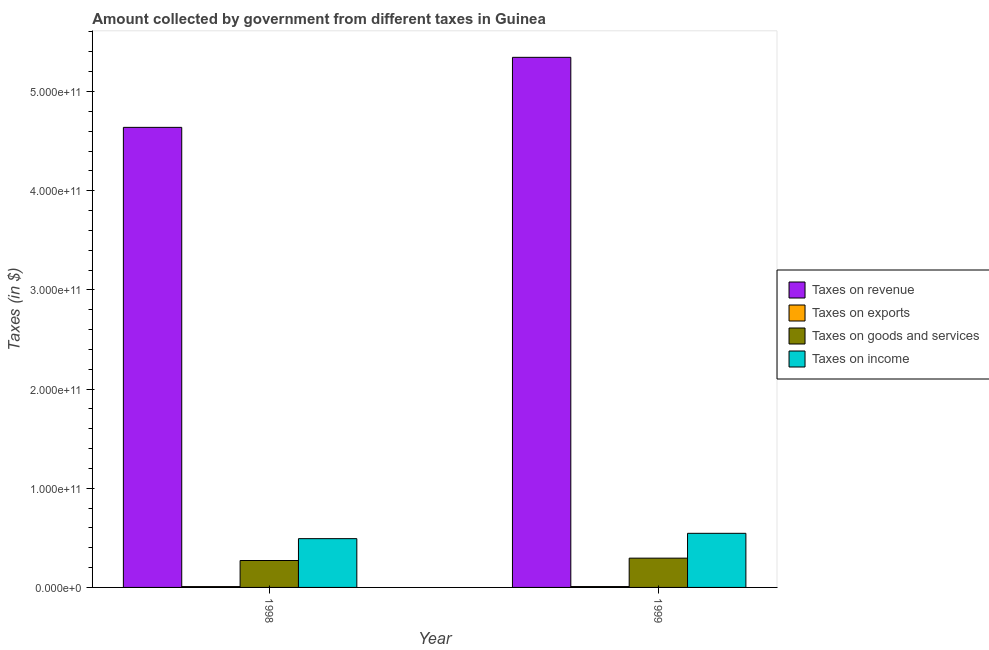How many groups of bars are there?
Offer a very short reply. 2. Are the number of bars per tick equal to the number of legend labels?
Offer a terse response. Yes. Are the number of bars on each tick of the X-axis equal?
Your answer should be compact. Yes. How many bars are there on the 1st tick from the left?
Keep it short and to the point. 4. What is the label of the 2nd group of bars from the left?
Give a very brief answer. 1999. What is the amount collected as tax on exports in 1999?
Make the answer very short. 8.80e+08. Across all years, what is the maximum amount collected as tax on revenue?
Keep it short and to the point. 5.34e+11. Across all years, what is the minimum amount collected as tax on income?
Provide a short and direct response. 4.92e+1. What is the total amount collected as tax on income in the graph?
Provide a succinct answer. 1.04e+11. What is the difference between the amount collected as tax on goods in 1998 and that in 1999?
Offer a terse response. -2.39e+09. What is the difference between the amount collected as tax on exports in 1998 and the amount collected as tax on income in 1999?
Provide a short and direct response. -3.90e+07. What is the average amount collected as tax on income per year?
Offer a terse response. 5.19e+1. What is the ratio of the amount collected as tax on goods in 1998 to that in 1999?
Provide a succinct answer. 0.92. In how many years, is the amount collected as tax on exports greater than the average amount collected as tax on exports taken over all years?
Keep it short and to the point. 1. What does the 1st bar from the left in 1998 represents?
Make the answer very short. Taxes on revenue. What does the 4th bar from the right in 1999 represents?
Make the answer very short. Taxes on revenue. Is it the case that in every year, the sum of the amount collected as tax on revenue and amount collected as tax on exports is greater than the amount collected as tax on goods?
Your response must be concise. Yes. How many bars are there?
Ensure brevity in your answer.  8. Are all the bars in the graph horizontal?
Offer a very short reply. No. What is the difference between two consecutive major ticks on the Y-axis?
Give a very brief answer. 1.00e+11. Does the graph contain any zero values?
Offer a terse response. No. Does the graph contain grids?
Offer a terse response. No. How many legend labels are there?
Ensure brevity in your answer.  4. What is the title of the graph?
Make the answer very short. Amount collected by government from different taxes in Guinea. Does "Quality of logistic services" appear as one of the legend labels in the graph?
Provide a short and direct response. No. What is the label or title of the Y-axis?
Provide a succinct answer. Taxes (in $). What is the Taxes (in $) of Taxes on revenue in 1998?
Make the answer very short. 4.64e+11. What is the Taxes (in $) in Taxes on exports in 1998?
Offer a very short reply. 8.41e+08. What is the Taxes (in $) in Taxes on goods and services in 1998?
Offer a very short reply. 2.71e+1. What is the Taxes (in $) in Taxes on income in 1998?
Keep it short and to the point. 4.92e+1. What is the Taxes (in $) of Taxes on revenue in 1999?
Provide a succinct answer. 5.34e+11. What is the Taxes (in $) in Taxes on exports in 1999?
Give a very brief answer. 8.80e+08. What is the Taxes (in $) in Taxes on goods and services in 1999?
Your response must be concise. 2.95e+1. What is the Taxes (in $) in Taxes on income in 1999?
Provide a succinct answer. 5.46e+1. Across all years, what is the maximum Taxes (in $) of Taxes on revenue?
Keep it short and to the point. 5.34e+11. Across all years, what is the maximum Taxes (in $) of Taxes on exports?
Ensure brevity in your answer.  8.80e+08. Across all years, what is the maximum Taxes (in $) in Taxes on goods and services?
Your response must be concise. 2.95e+1. Across all years, what is the maximum Taxes (in $) in Taxes on income?
Provide a succinct answer. 5.46e+1. Across all years, what is the minimum Taxes (in $) of Taxes on revenue?
Your answer should be compact. 4.64e+11. Across all years, what is the minimum Taxes (in $) in Taxes on exports?
Give a very brief answer. 8.41e+08. Across all years, what is the minimum Taxes (in $) in Taxes on goods and services?
Ensure brevity in your answer.  2.71e+1. Across all years, what is the minimum Taxes (in $) in Taxes on income?
Provide a short and direct response. 4.92e+1. What is the total Taxes (in $) in Taxes on revenue in the graph?
Provide a succinct answer. 9.98e+11. What is the total Taxes (in $) in Taxes on exports in the graph?
Give a very brief answer. 1.72e+09. What is the total Taxes (in $) of Taxes on goods and services in the graph?
Your response must be concise. 5.67e+1. What is the total Taxes (in $) in Taxes on income in the graph?
Your answer should be very brief. 1.04e+11. What is the difference between the Taxes (in $) in Taxes on revenue in 1998 and that in 1999?
Keep it short and to the point. -7.06e+1. What is the difference between the Taxes (in $) in Taxes on exports in 1998 and that in 1999?
Your response must be concise. -3.90e+07. What is the difference between the Taxes (in $) in Taxes on goods and services in 1998 and that in 1999?
Provide a short and direct response. -2.39e+09. What is the difference between the Taxes (in $) of Taxes on income in 1998 and that in 1999?
Your answer should be compact. -5.38e+09. What is the difference between the Taxes (in $) in Taxes on revenue in 1998 and the Taxes (in $) in Taxes on exports in 1999?
Provide a short and direct response. 4.63e+11. What is the difference between the Taxes (in $) in Taxes on revenue in 1998 and the Taxes (in $) in Taxes on goods and services in 1999?
Provide a succinct answer. 4.34e+11. What is the difference between the Taxes (in $) of Taxes on revenue in 1998 and the Taxes (in $) of Taxes on income in 1999?
Provide a succinct answer. 4.09e+11. What is the difference between the Taxes (in $) in Taxes on exports in 1998 and the Taxes (in $) in Taxes on goods and services in 1999?
Your answer should be very brief. -2.87e+1. What is the difference between the Taxes (in $) of Taxes on exports in 1998 and the Taxes (in $) of Taxes on income in 1999?
Offer a very short reply. -5.37e+1. What is the difference between the Taxes (in $) in Taxes on goods and services in 1998 and the Taxes (in $) in Taxes on income in 1999?
Offer a terse response. -2.74e+1. What is the average Taxes (in $) in Taxes on revenue per year?
Your answer should be very brief. 4.99e+11. What is the average Taxes (in $) in Taxes on exports per year?
Provide a short and direct response. 8.60e+08. What is the average Taxes (in $) of Taxes on goods and services per year?
Provide a succinct answer. 2.83e+1. What is the average Taxes (in $) in Taxes on income per year?
Provide a succinct answer. 5.19e+1. In the year 1998, what is the difference between the Taxes (in $) of Taxes on revenue and Taxes (in $) of Taxes on exports?
Your answer should be very brief. 4.63e+11. In the year 1998, what is the difference between the Taxes (in $) of Taxes on revenue and Taxes (in $) of Taxes on goods and services?
Give a very brief answer. 4.37e+11. In the year 1998, what is the difference between the Taxes (in $) of Taxes on revenue and Taxes (in $) of Taxes on income?
Provide a short and direct response. 4.15e+11. In the year 1998, what is the difference between the Taxes (in $) in Taxes on exports and Taxes (in $) in Taxes on goods and services?
Offer a very short reply. -2.63e+1. In the year 1998, what is the difference between the Taxes (in $) of Taxes on exports and Taxes (in $) of Taxes on income?
Offer a terse response. -4.83e+1. In the year 1998, what is the difference between the Taxes (in $) of Taxes on goods and services and Taxes (in $) of Taxes on income?
Your answer should be compact. -2.20e+1. In the year 1999, what is the difference between the Taxes (in $) in Taxes on revenue and Taxes (in $) in Taxes on exports?
Provide a succinct answer. 5.34e+11. In the year 1999, what is the difference between the Taxes (in $) in Taxes on revenue and Taxes (in $) in Taxes on goods and services?
Your response must be concise. 5.05e+11. In the year 1999, what is the difference between the Taxes (in $) of Taxes on revenue and Taxes (in $) of Taxes on income?
Ensure brevity in your answer.  4.80e+11. In the year 1999, what is the difference between the Taxes (in $) of Taxes on exports and Taxes (in $) of Taxes on goods and services?
Give a very brief answer. -2.86e+1. In the year 1999, what is the difference between the Taxes (in $) of Taxes on exports and Taxes (in $) of Taxes on income?
Your answer should be very brief. -5.37e+1. In the year 1999, what is the difference between the Taxes (in $) in Taxes on goods and services and Taxes (in $) in Taxes on income?
Your response must be concise. -2.50e+1. What is the ratio of the Taxes (in $) of Taxes on revenue in 1998 to that in 1999?
Ensure brevity in your answer.  0.87. What is the ratio of the Taxes (in $) of Taxes on exports in 1998 to that in 1999?
Your response must be concise. 0.96. What is the ratio of the Taxes (in $) of Taxes on goods and services in 1998 to that in 1999?
Your response must be concise. 0.92. What is the ratio of the Taxes (in $) of Taxes on income in 1998 to that in 1999?
Make the answer very short. 0.9. What is the difference between the highest and the second highest Taxes (in $) of Taxes on revenue?
Give a very brief answer. 7.06e+1. What is the difference between the highest and the second highest Taxes (in $) in Taxes on exports?
Provide a succinct answer. 3.90e+07. What is the difference between the highest and the second highest Taxes (in $) of Taxes on goods and services?
Offer a terse response. 2.39e+09. What is the difference between the highest and the second highest Taxes (in $) of Taxes on income?
Give a very brief answer. 5.38e+09. What is the difference between the highest and the lowest Taxes (in $) of Taxes on revenue?
Provide a succinct answer. 7.06e+1. What is the difference between the highest and the lowest Taxes (in $) of Taxes on exports?
Ensure brevity in your answer.  3.90e+07. What is the difference between the highest and the lowest Taxes (in $) in Taxes on goods and services?
Offer a very short reply. 2.39e+09. What is the difference between the highest and the lowest Taxes (in $) of Taxes on income?
Give a very brief answer. 5.38e+09. 